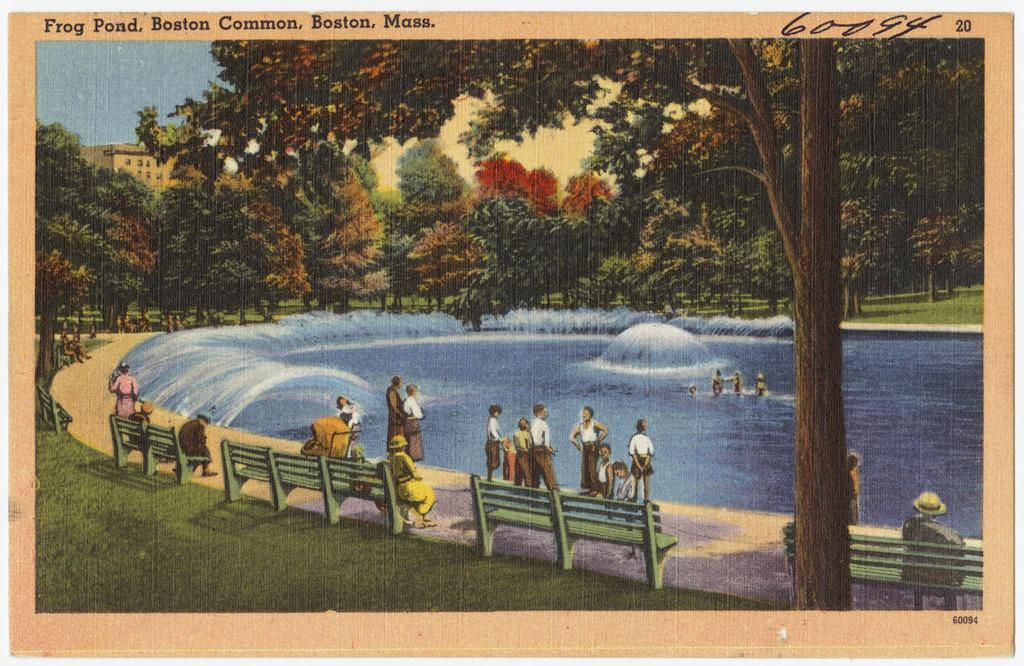Provide a one-sentence caption for the provided image. A post card from Frog Pond, Boston Commons, Boston, Mass. 